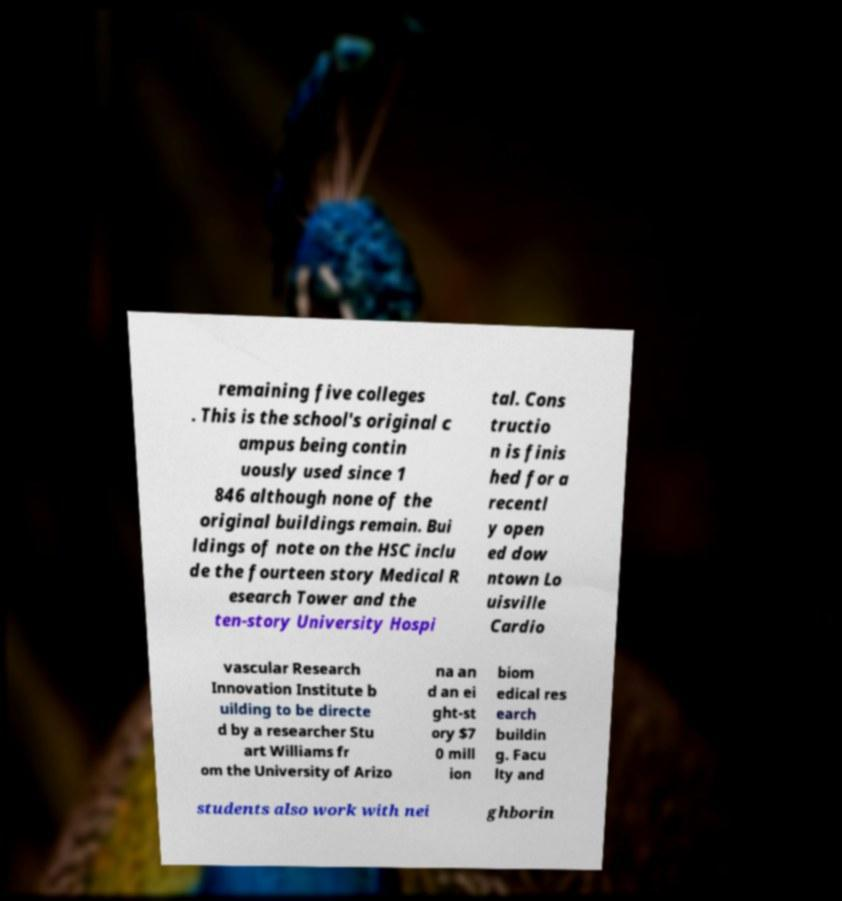Could you extract and type out the text from this image? remaining five colleges . This is the school's original c ampus being contin uously used since 1 846 although none of the original buildings remain. Bui ldings of note on the HSC inclu de the fourteen story Medical R esearch Tower and the ten-story University Hospi tal. Cons tructio n is finis hed for a recentl y open ed dow ntown Lo uisville Cardio vascular Research Innovation Institute b uilding to be directe d by a researcher Stu art Williams fr om the University of Arizo na an d an ei ght-st ory $7 0 mill ion biom edical res earch buildin g. Facu lty and students also work with nei ghborin 